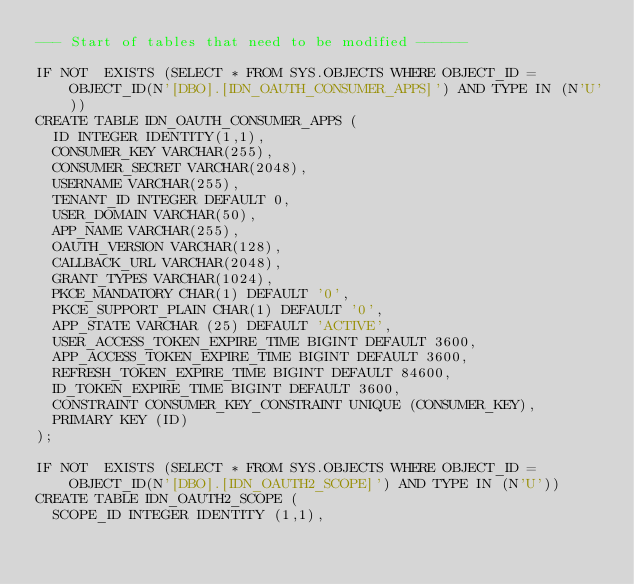Convert code to text. <code><loc_0><loc_0><loc_500><loc_500><_SQL_>--- Start of tables that need to be modified ------

IF NOT  EXISTS (SELECT * FROM SYS.OBJECTS WHERE OBJECT_ID = OBJECT_ID(N'[DBO].[IDN_OAUTH_CONSUMER_APPS]') AND TYPE IN (N'U'))
CREATE TABLE IDN_OAUTH_CONSUMER_APPS (
  ID INTEGER IDENTITY(1,1),
  CONSUMER_KEY VARCHAR(255),
  CONSUMER_SECRET VARCHAR(2048),
  USERNAME VARCHAR(255),
  TENANT_ID INTEGER DEFAULT 0,
  USER_DOMAIN VARCHAR(50),
  APP_NAME VARCHAR(255),
  OAUTH_VERSION VARCHAR(128),
  CALLBACK_URL VARCHAR(2048),
  GRANT_TYPES VARCHAR(1024),
  PKCE_MANDATORY CHAR(1) DEFAULT '0',
  PKCE_SUPPORT_PLAIN CHAR(1) DEFAULT '0',
  APP_STATE VARCHAR (25) DEFAULT 'ACTIVE',
  USER_ACCESS_TOKEN_EXPIRE_TIME BIGINT DEFAULT 3600,
  APP_ACCESS_TOKEN_EXPIRE_TIME BIGINT DEFAULT 3600,
  REFRESH_TOKEN_EXPIRE_TIME BIGINT DEFAULT 84600,
  ID_TOKEN_EXPIRE_TIME BIGINT DEFAULT 3600,
  CONSTRAINT CONSUMER_KEY_CONSTRAINT UNIQUE (CONSUMER_KEY),
  PRIMARY KEY (ID)
);

IF NOT  EXISTS (SELECT * FROM SYS.OBJECTS WHERE OBJECT_ID = OBJECT_ID(N'[DBO].[IDN_OAUTH2_SCOPE]') AND TYPE IN (N'U'))
CREATE TABLE IDN_OAUTH2_SCOPE (
  SCOPE_ID INTEGER IDENTITY (1,1),</code> 